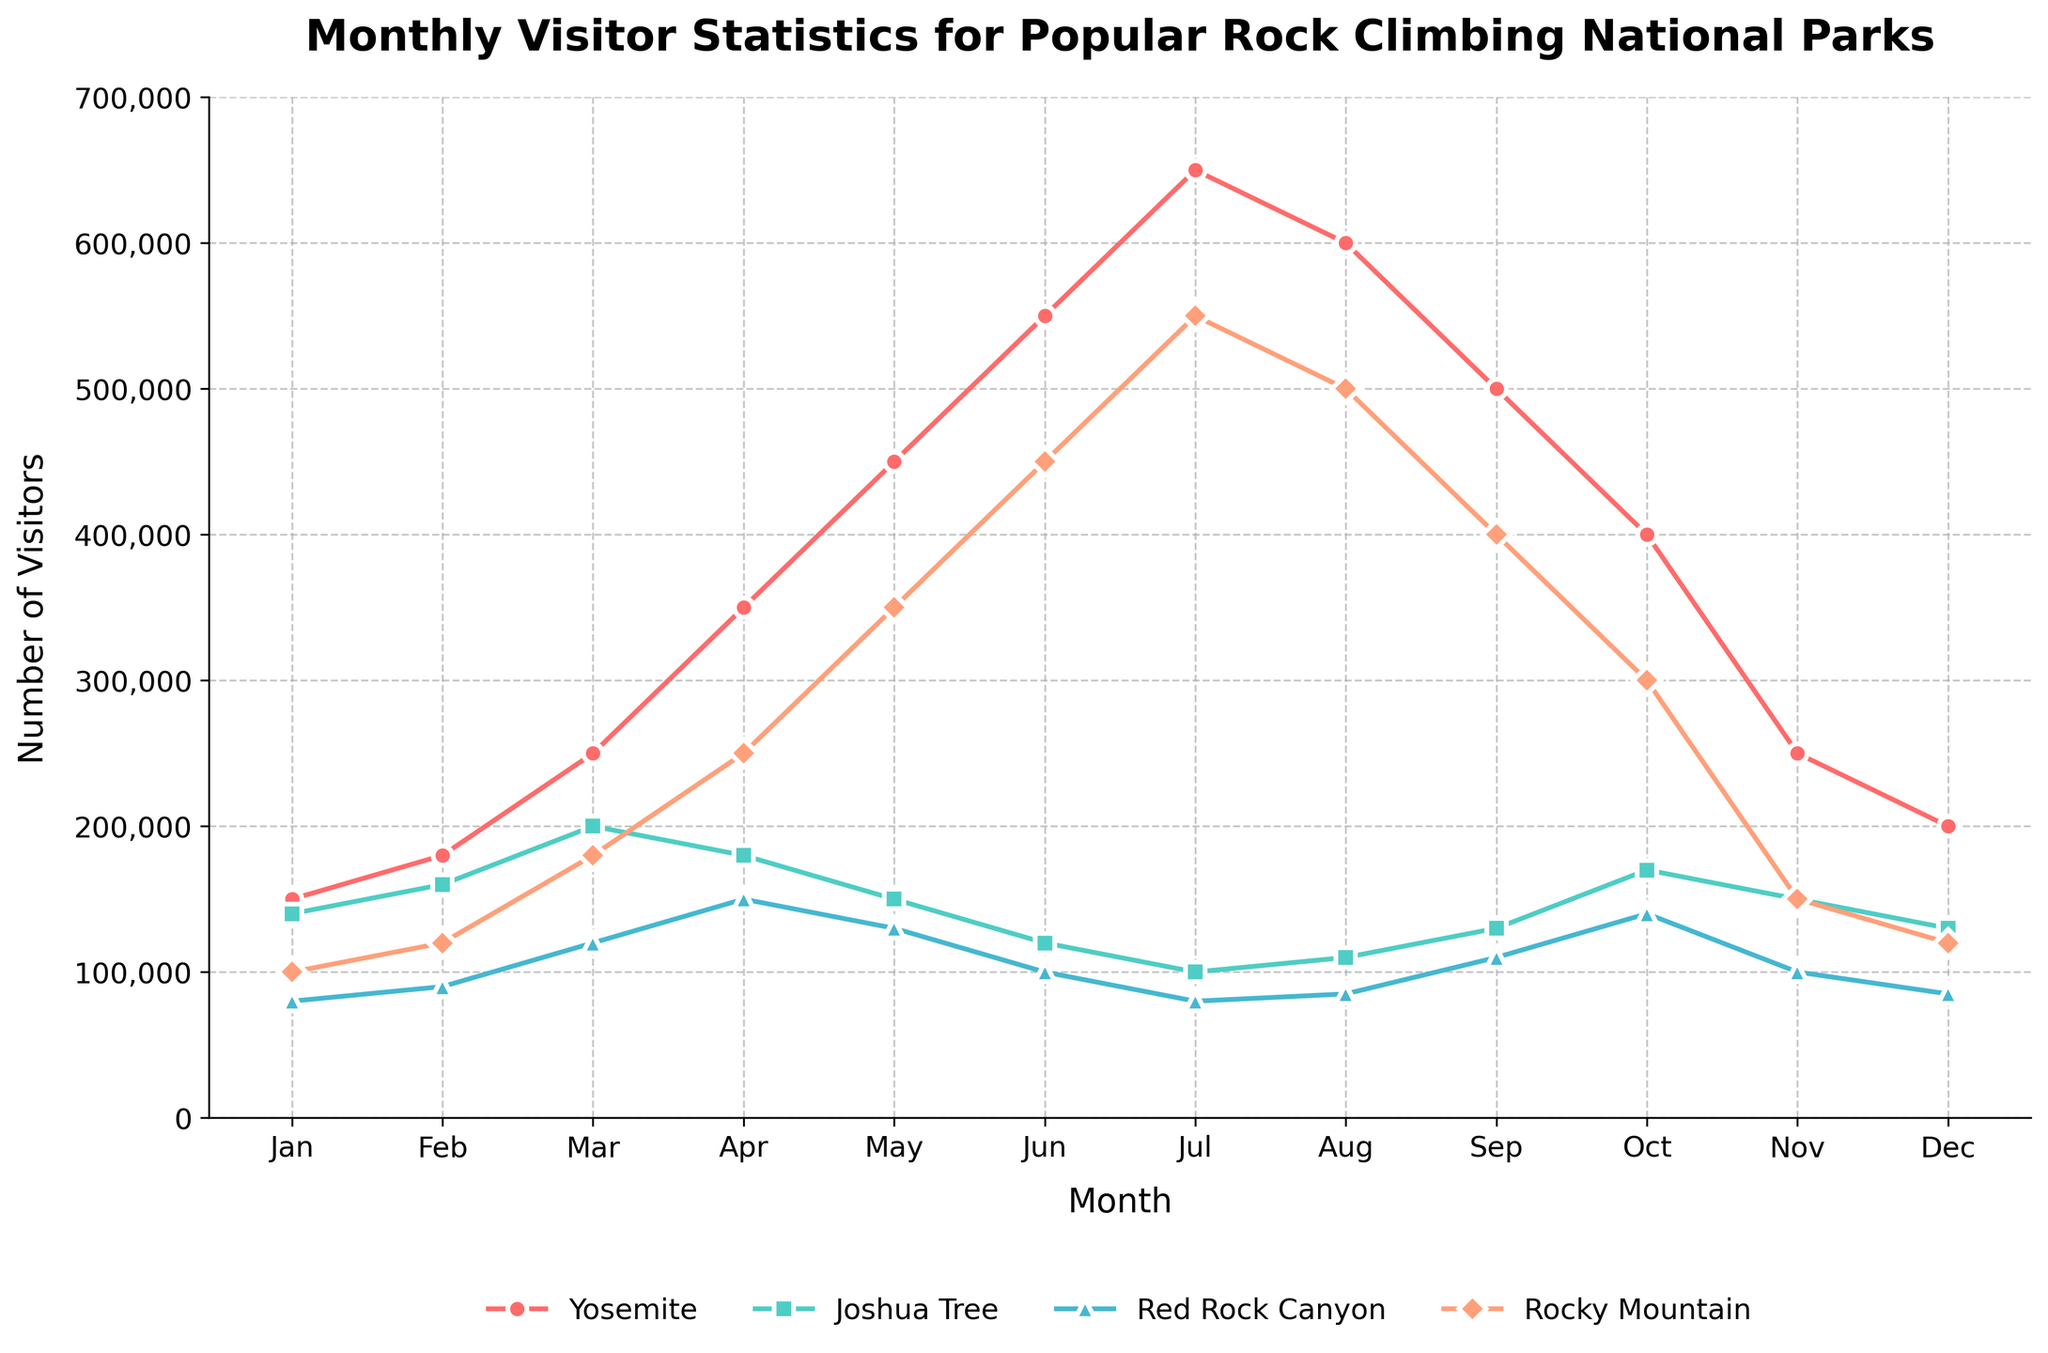Which park had the highest number of visitors in July? Look at the data points for July and compare the number of visitors for each park. Yosemite had the highest number at 650,000.
Answer: Yosemite How does the number of visitors to Joshua Tree in January compare to those in December? Find the data points for Joshua Tree in January (140,000) and December (130,000). January had more visitors.
Answer: January had more What's the average number of visitors to Red Rock Canyon from June to August? Sum the visitors for Red Rock Canyon in June (100,000), July (80,000), and August (85,000). The total is 265,000. Divide by 3 months to get the average: 265,000 / 3 = 88,333.33.
Answer: 88,333 Which month has the lowest number of visitors in Rocky Mountain and how many visitors were there? Look through the Monthly data points for Rocky Mountain and find the lowest value. January had the lowest with 100,000 visitors.
Answer: January, 100,000 Compare the visitor trends for Yosemite and Rocky Mountain. In which months do they both experience a peak? Visually inspect the trend lines for both parks. Both have peaks in July. Yosemite has a peak at 650,000 and Rocky Mountain at 550,000 in July.
Answer: July What is the difference in visitors between Joshua Tree and Red Rock Canyon in April? Find the April data for both parks: Joshua Tree (180,000) and Red Rock Canyon (150,000). The difference is 180,000 - 150,000 = 30,000.
Answer: 30,000 In which month do all parks see a rise in visitors compared to the previous month? Compare data month over month for all parks and see where all values increase. From February to March, all parks see an increase.
Answer: March Which park shows the most consistent visitor trend through the year and why? Visually inspect the trend lines and see which one has the least fluctuation. Joshua Tree has a relatively more consistent trend compared to others.
Answer: Joshua Tree During which months do Yosemite and Joshua Tree see a decline in visitors compared to the previous month? Compare month-to-month data for both Yosemite and Joshua Tree. For Yosemite, it declines in August, and for Joshua Tree in May and October.
Answer: August for Yosemite; May and October for Joshua Tree How many total visitors did Rocky Mountain have from May to July? Sum the visitors for Rocky Mountain in May (350,000), June (450,000), and July (550,000). The total is 350,000 + 450,000 + 550,000 = 1,350,000.
Answer: 1,350,000 